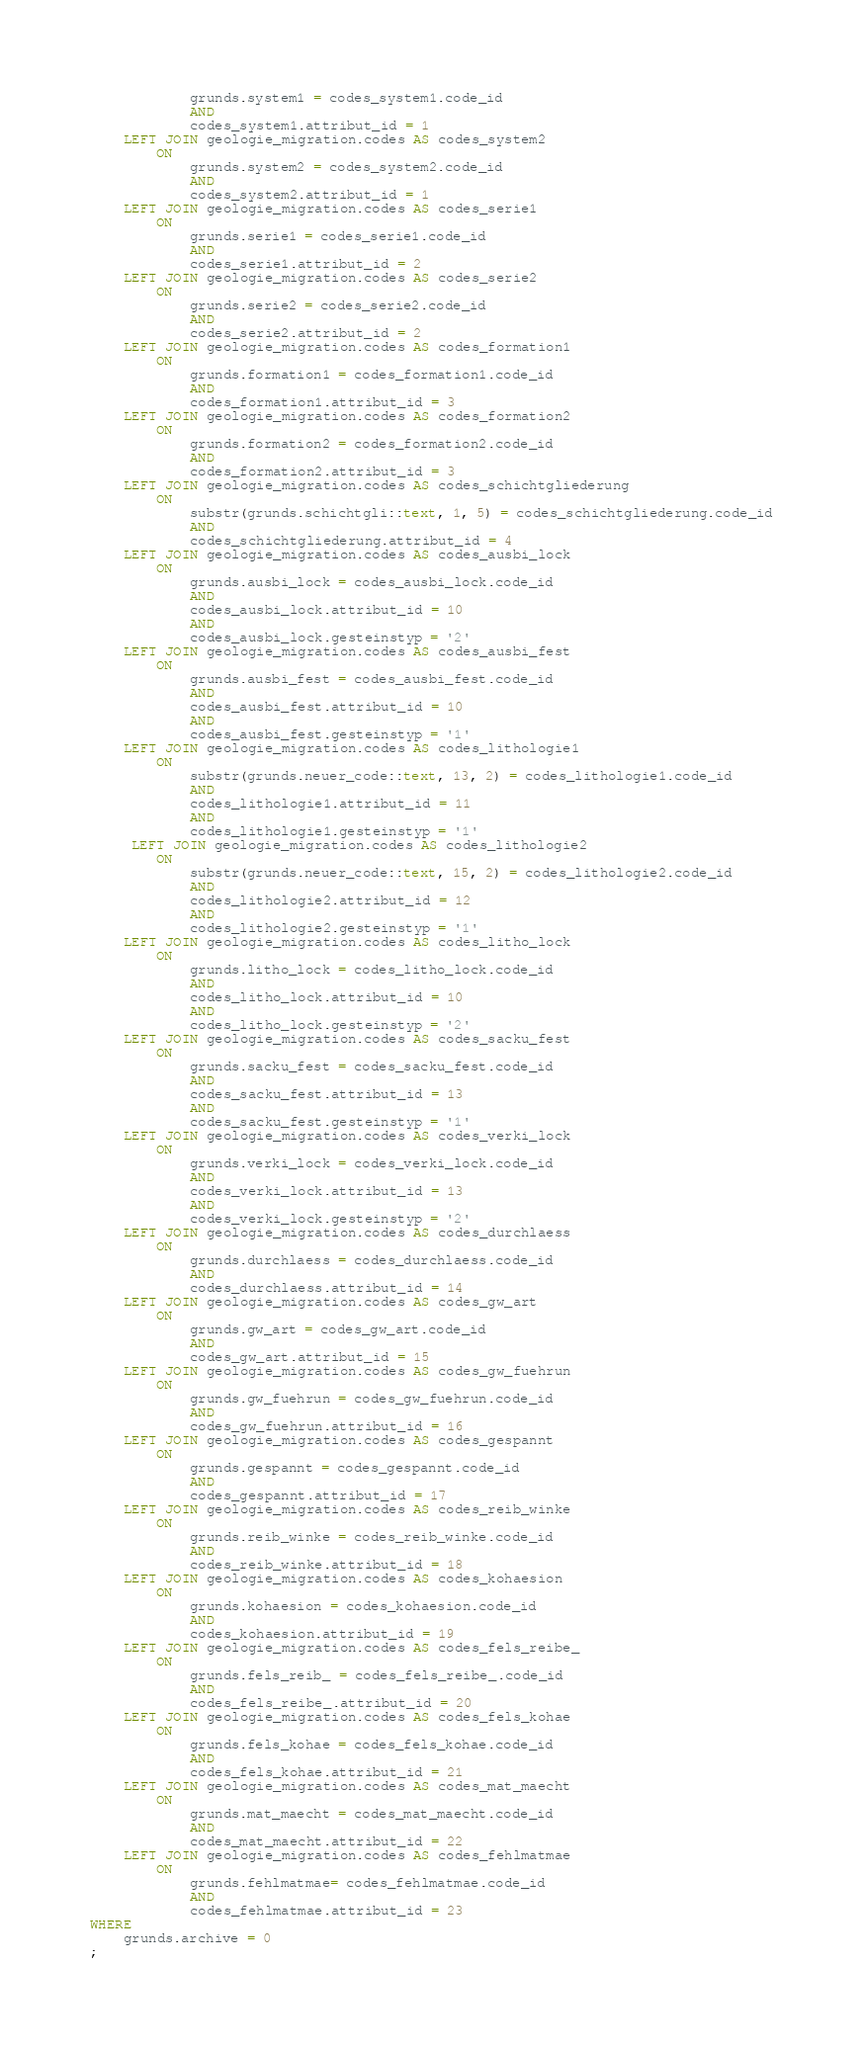Convert code to text. <code><loc_0><loc_0><loc_500><loc_500><_SQL_>            grunds.system1 = codes_system1.code_id
            AND 
            codes_system1.attribut_id = 1
    LEFT JOIN geologie_migration.codes AS codes_system2
        ON 
            grunds.system2 = codes_system2.code_id
            AND 
            codes_system2.attribut_id = 1
    LEFT JOIN geologie_migration.codes AS codes_serie1
        ON 
            grunds.serie1 = codes_serie1.code_id
            AND 
            codes_serie1.attribut_id = 2
    LEFT JOIN geologie_migration.codes AS codes_serie2
        ON 
            grunds.serie2 = codes_serie2.code_id
            AND 
            codes_serie2.attribut_id = 2
    LEFT JOIN geologie_migration.codes AS codes_formation1
        ON 
            grunds.formation1 = codes_formation1.code_id
            AND 
            codes_formation1.attribut_id = 3
    LEFT JOIN geologie_migration.codes AS codes_formation2
        ON 
            grunds.formation2 = codes_formation2.code_id
            AND 
            codes_formation2.attribut_id = 3
    LEFT JOIN geologie_migration.codes AS codes_schichtgliederung
        ON 
            substr(grunds.schichtgli::text, 1, 5) = codes_schichtgliederung.code_id
            AND 
            codes_schichtgliederung.attribut_id = 4
    LEFT JOIN geologie_migration.codes AS codes_ausbi_lock
        ON 
            grunds.ausbi_lock = codes_ausbi_lock.code_id
            AND
            codes_ausbi_lock.attribut_id = 10
            AND
            codes_ausbi_lock.gesteinstyp = '2'
    LEFT JOIN geologie_migration.codes AS codes_ausbi_fest
        ON 
            grunds.ausbi_fest = codes_ausbi_fest.code_id
            AND 
            codes_ausbi_fest.attribut_id = 10
            AND
            codes_ausbi_fest.gesteinstyp = '1'
    LEFT JOIN geologie_migration.codes AS codes_lithologie1
        ON 
            substr(grunds.neuer_code::text, 13, 2) = codes_lithologie1.code_id
            AND 
            codes_lithologie1.attribut_id = 11
            AND
            codes_lithologie1.gesteinstyp = '1'
     LEFT JOIN geologie_migration.codes AS codes_lithologie2
        ON 
            substr(grunds.neuer_code::text, 15, 2) = codes_lithologie2.code_id
            AND 
            codes_lithologie2.attribut_id = 12
            AND
            codes_lithologie2.gesteinstyp = '1'
    LEFT JOIN geologie_migration.codes AS codes_litho_lock
        ON 
            grunds.litho_lock = codes_litho_lock.code_id
            AND
            codes_litho_lock.attribut_id = 10
            AND
            codes_litho_lock.gesteinstyp = '2'
    LEFT JOIN geologie_migration.codes AS codes_sacku_fest
        ON 
            grunds.sacku_fest = codes_sacku_fest.code_id
            AND 
            codes_sacku_fest.attribut_id = 13
            AND
            codes_sacku_fest.gesteinstyp = '1'
    LEFT JOIN geologie_migration.codes AS codes_verki_lock
        ON 
            grunds.verki_lock = codes_verki_lock.code_id
            AND
            codes_verki_lock.attribut_id = 13
            AND
            codes_verki_lock.gesteinstyp = '2'
    LEFT JOIN geologie_migration.codes AS codes_durchlaess
        ON 
            grunds.durchlaess = codes_durchlaess.code_id
            AND 
            codes_durchlaess.attribut_id = 14
    LEFT JOIN geologie_migration.codes AS codes_gw_art
        ON 
            grunds.gw_art = codes_gw_art.code_id
            AND 
            codes_gw_art.attribut_id = 15
    LEFT JOIN geologie_migration.codes AS codes_gw_fuehrun
        ON 
            grunds.gw_fuehrun = codes_gw_fuehrun.code_id
            AND 
            codes_gw_fuehrun.attribut_id = 16
    LEFT JOIN geologie_migration.codes AS codes_gespannt
        ON 
            grunds.gespannt = codes_gespannt.code_id
            AND 
            codes_gespannt.attribut_id = 17
    LEFT JOIN geologie_migration.codes AS codes_reib_winke
        ON 
            grunds.reib_winke = codes_reib_winke.code_id
            AND 
            codes_reib_winke.attribut_id = 18
    LEFT JOIN geologie_migration.codes AS codes_kohaesion
        ON 
            grunds.kohaesion = codes_kohaesion.code_id
            AND 
            codes_kohaesion.attribut_id = 19
    LEFT JOIN geologie_migration.codes AS codes_fels_reibe_
        ON 
            grunds.fels_reib_ = codes_fels_reibe_.code_id
            AND 
            codes_fels_reibe_.attribut_id = 20
    LEFT JOIN geologie_migration.codes AS codes_fels_kohae
        ON 
            grunds.fels_kohae = codes_fels_kohae.code_id
            AND 
            codes_fels_kohae.attribut_id = 21
    LEFT JOIN geologie_migration.codes AS codes_mat_maecht
        ON 
            grunds.mat_maecht = codes_mat_maecht.code_id
            AND 
            codes_mat_maecht.attribut_id = 22
    LEFT JOIN geologie_migration.codes AS codes_fehlmatmae
        ON 
            grunds.fehlmatmae= codes_fehlmatmae.code_id
            AND 
            codes_fehlmatmae.attribut_id = 23
WHERE 
    grunds.archive = 0
;
</code> 